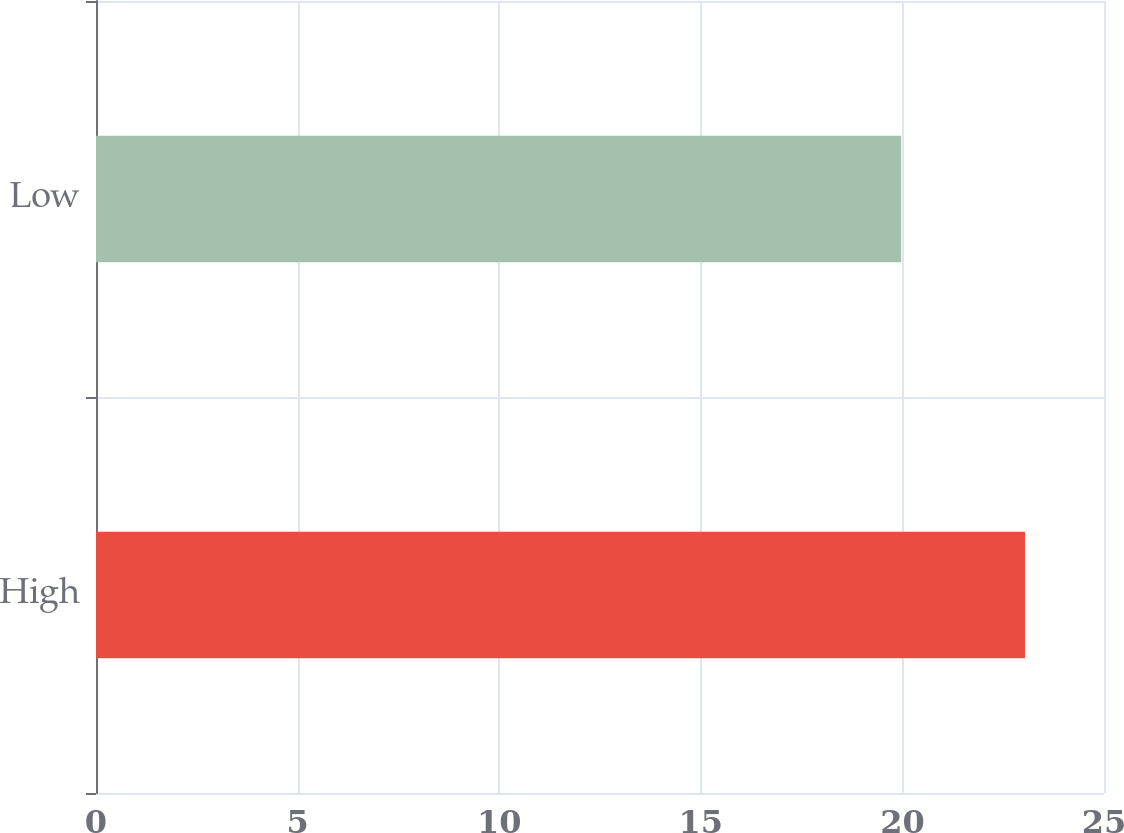Convert chart to OTSL. <chart><loc_0><loc_0><loc_500><loc_500><bar_chart><fcel>High<fcel>Low<nl><fcel>23.04<fcel>19.97<nl></chart> 